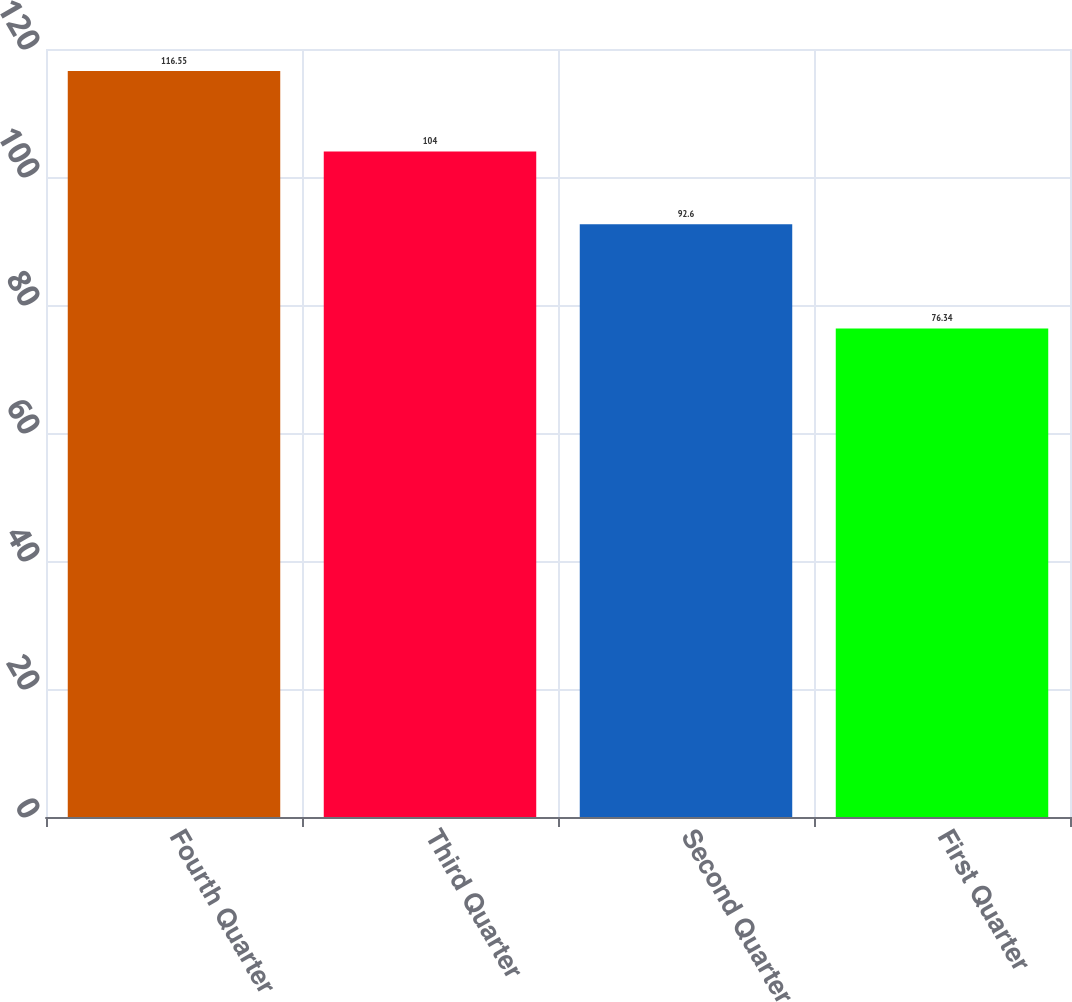<chart> <loc_0><loc_0><loc_500><loc_500><bar_chart><fcel>Fourth Quarter<fcel>Third Quarter<fcel>Second Quarter<fcel>First Quarter<nl><fcel>116.55<fcel>104<fcel>92.6<fcel>76.34<nl></chart> 